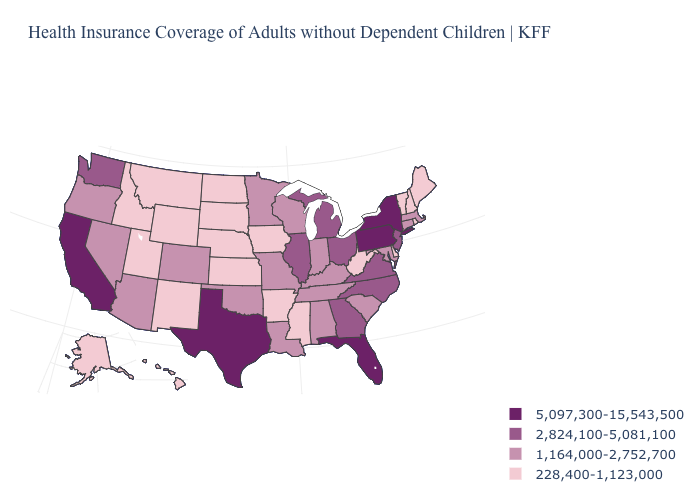What is the highest value in states that border South Carolina?
Write a very short answer. 2,824,100-5,081,100. Name the states that have a value in the range 1,164,000-2,752,700?
Quick response, please. Alabama, Arizona, Colorado, Connecticut, Indiana, Kentucky, Louisiana, Maryland, Massachusetts, Minnesota, Missouri, Nevada, Oklahoma, Oregon, South Carolina, Tennessee, Wisconsin. Name the states that have a value in the range 2,824,100-5,081,100?
Quick response, please. Georgia, Illinois, Michigan, New Jersey, North Carolina, Ohio, Virginia, Washington. What is the value of Missouri?
Give a very brief answer. 1,164,000-2,752,700. Does Pennsylvania have the lowest value in the Northeast?
Be succinct. No. What is the highest value in the USA?
Keep it brief. 5,097,300-15,543,500. What is the highest value in states that border Alabama?
Be succinct. 5,097,300-15,543,500. Name the states that have a value in the range 1,164,000-2,752,700?
Write a very short answer. Alabama, Arizona, Colorado, Connecticut, Indiana, Kentucky, Louisiana, Maryland, Massachusetts, Minnesota, Missouri, Nevada, Oklahoma, Oregon, South Carolina, Tennessee, Wisconsin. Name the states that have a value in the range 5,097,300-15,543,500?
Write a very short answer. California, Florida, New York, Pennsylvania, Texas. What is the value of Montana?
Concise answer only. 228,400-1,123,000. What is the highest value in the USA?
Quick response, please. 5,097,300-15,543,500. Does Florida have the highest value in the South?
Write a very short answer. Yes. Does Wisconsin have a lower value than Oklahoma?
Concise answer only. No. Among the states that border Virginia , does Tennessee have the lowest value?
Write a very short answer. No. What is the highest value in the MidWest ?
Short answer required. 2,824,100-5,081,100. 